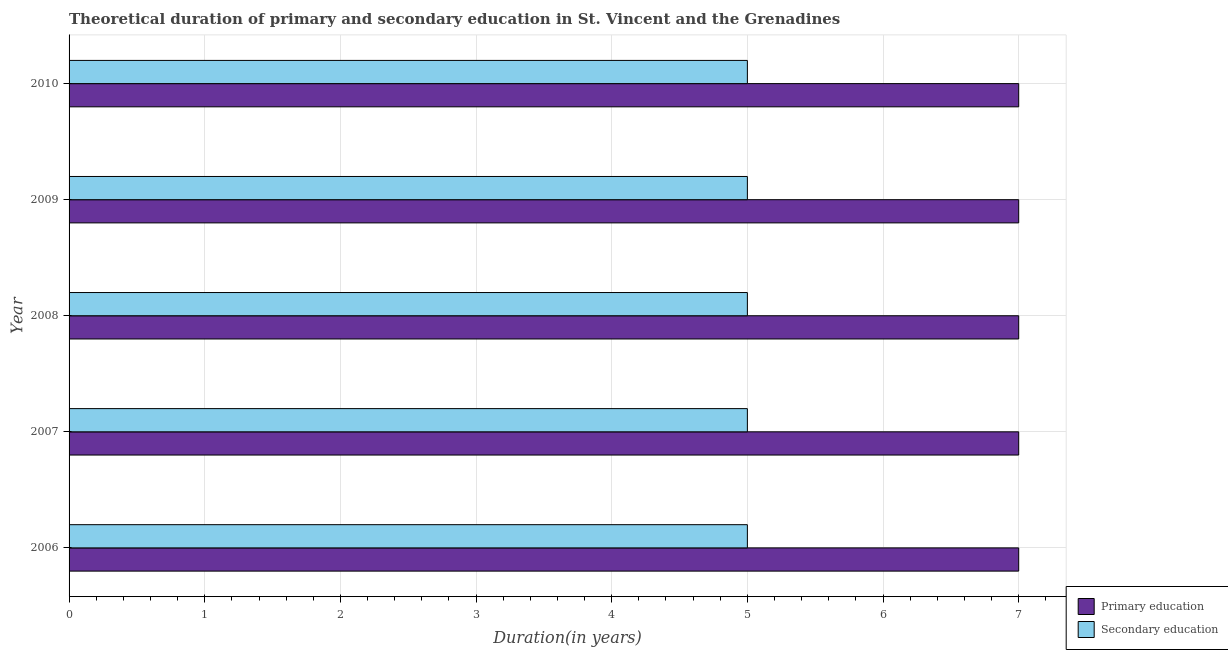How many different coloured bars are there?
Provide a succinct answer. 2. How many groups of bars are there?
Your response must be concise. 5. How many bars are there on the 4th tick from the bottom?
Offer a terse response. 2. What is the label of the 3rd group of bars from the top?
Ensure brevity in your answer.  2008. In how many cases, is the number of bars for a given year not equal to the number of legend labels?
Give a very brief answer. 0. What is the duration of secondary education in 2008?
Offer a very short reply. 5. Across all years, what is the maximum duration of primary education?
Keep it short and to the point. 7. Across all years, what is the minimum duration of primary education?
Ensure brevity in your answer.  7. In which year was the duration of secondary education maximum?
Make the answer very short. 2006. What is the total duration of primary education in the graph?
Your answer should be very brief. 35. What is the difference between the duration of secondary education in 2009 and that in 2010?
Ensure brevity in your answer.  0. What is the difference between the duration of primary education in 2006 and the duration of secondary education in 2007?
Ensure brevity in your answer.  2. In the year 2006, what is the difference between the duration of secondary education and duration of primary education?
Offer a very short reply. -2. Is the duration of secondary education in 2007 less than that in 2010?
Ensure brevity in your answer.  No. Is the difference between the duration of secondary education in 2007 and 2010 greater than the difference between the duration of primary education in 2007 and 2010?
Provide a succinct answer. No. What is the difference between the highest and the second highest duration of primary education?
Your answer should be compact. 0. What is the difference between the highest and the lowest duration of primary education?
Keep it short and to the point. 0. In how many years, is the duration of primary education greater than the average duration of primary education taken over all years?
Ensure brevity in your answer.  0. Is the sum of the duration of primary education in 2009 and 2010 greater than the maximum duration of secondary education across all years?
Keep it short and to the point. Yes. What does the 2nd bar from the bottom in 2010 represents?
Make the answer very short. Secondary education. How are the legend labels stacked?
Your answer should be compact. Vertical. What is the title of the graph?
Provide a succinct answer. Theoretical duration of primary and secondary education in St. Vincent and the Grenadines. What is the label or title of the X-axis?
Offer a terse response. Duration(in years). What is the Duration(in years) in Primary education in 2006?
Provide a short and direct response. 7. What is the Duration(in years) of Primary education in 2007?
Ensure brevity in your answer.  7. What is the Duration(in years) of Secondary education in 2007?
Your answer should be compact. 5. What is the Duration(in years) in Primary education in 2008?
Give a very brief answer. 7. What is the Duration(in years) in Primary education in 2010?
Give a very brief answer. 7. What is the Duration(in years) of Secondary education in 2010?
Provide a succinct answer. 5. Across all years, what is the maximum Duration(in years) in Secondary education?
Ensure brevity in your answer.  5. Across all years, what is the minimum Duration(in years) in Primary education?
Provide a short and direct response. 7. Across all years, what is the minimum Duration(in years) of Secondary education?
Ensure brevity in your answer.  5. What is the difference between the Duration(in years) in Primary education in 2006 and that in 2007?
Give a very brief answer. 0. What is the difference between the Duration(in years) in Secondary education in 2006 and that in 2007?
Ensure brevity in your answer.  0. What is the difference between the Duration(in years) of Secondary education in 2006 and that in 2008?
Ensure brevity in your answer.  0. What is the difference between the Duration(in years) of Primary education in 2007 and that in 2008?
Offer a very short reply. 0. What is the difference between the Duration(in years) in Secondary education in 2007 and that in 2008?
Your answer should be very brief. 0. What is the difference between the Duration(in years) in Primary education in 2007 and that in 2009?
Offer a very short reply. 0. What is the difference between the Duration(in years) of Secondary education in 2007 and that in 2010?
Provide a succinct answer. 0. What is the difference between the Duration(in years) in Secondary education in 2009 and that in 2010?
Your answer should be compact. 0. What is the difference between the Duration(in years) in Primary education in 2006 and the Duration(in years) in Secondary education in 2007?
Your answer should be very brief. 2. What is the difference between the Duration(in years) of Primary education in 2006 and the Duration(in years) of Secondary education in 2009?
Your answer should be compact. 2. What is the difference between the Duration(in years) in Primary education in 2008 and the Duration(in years) in Secondary education in 2010?
Your answer should be very brief. 2. What is the difference between the Duration(in years) of Primary education in 2009 and the Duration(in years) of Secondary education in 2010?
Ensure brevity in your answer.  2. What is the average Duration(in years) in Secondary education per year?
Your response must be concise. 5. In the year 2006, what is the difference between the Duration(in years) in Primary education and Duration(in years) in Secondary education?
Keep it short and to the point. 2. In the year 2008, what is the difference between the Duration(in years) in Primary education and Duration(in years) in Secondary education?
Keep it short and to the point. 2. In the year 2010, what is the difference between the Duration(in years) in Primary education and Duration(in years) in Secondary education?
Keep it short and to the point. 2. What is the ratio of the Duration(in years) in Primary education in 2006 to that in 2007?
Give a very brief answer. 1. What is the ratio of the Duration(in years) of Secondary education in 2006 to that in 2007?
Make the answer very short. 1. What is the ratio of the Duration(in years) in Primary education in 2006 to that in 2008?
Your answer should be very brief. 1. What is the ratio of the Duration(in years) in Primary education in 2006 to that in 2009?
Your response must be concise. 1. What is the ratio of the Duration(in years) in Secondary education in 2006 to that in 2009?
Provide a succinct answer. 1. What is the ratio of the Duration(in years) of Secondary education in 2006 to that in 2010?
Your answer should be compact. 1. What is the ratio of the Duration(in years) in Primary education in 2007 to that in 2009?
Offer a very short reply. 1. What is the ratio of the Duration(in years) in Primary education in 2007 to that in 2010?
Keep it short and to the point. 1. What is the ratio of the Duration(in years) in Secondary education in 2007 to that in 2010?
Offer a very short reply. 1. What is the ratio of the Duration(in years) in Secondary education in 2008 to that in 2009?
Your answer should be very brief. 1. What is the ratio of the Duration(in years) of Secondary education in 2008 to that in 2010?
Give a very brief answer. 1. What is the difference between the highest and the second highest Duration(in years) of Primary education?
Provide a short and direct response. 0. What is the difference between the highest and the second highest Duration(in years) of Secondary education?
Your answer should be compact. 0. What is the difference between the highest and the lowest Duration(in years) in Primary education?
Make the answer very short. 0. What is the difference between the highest and the lowest Duration(in years) of Secondary education?
Keep it short and to the point. 0. 